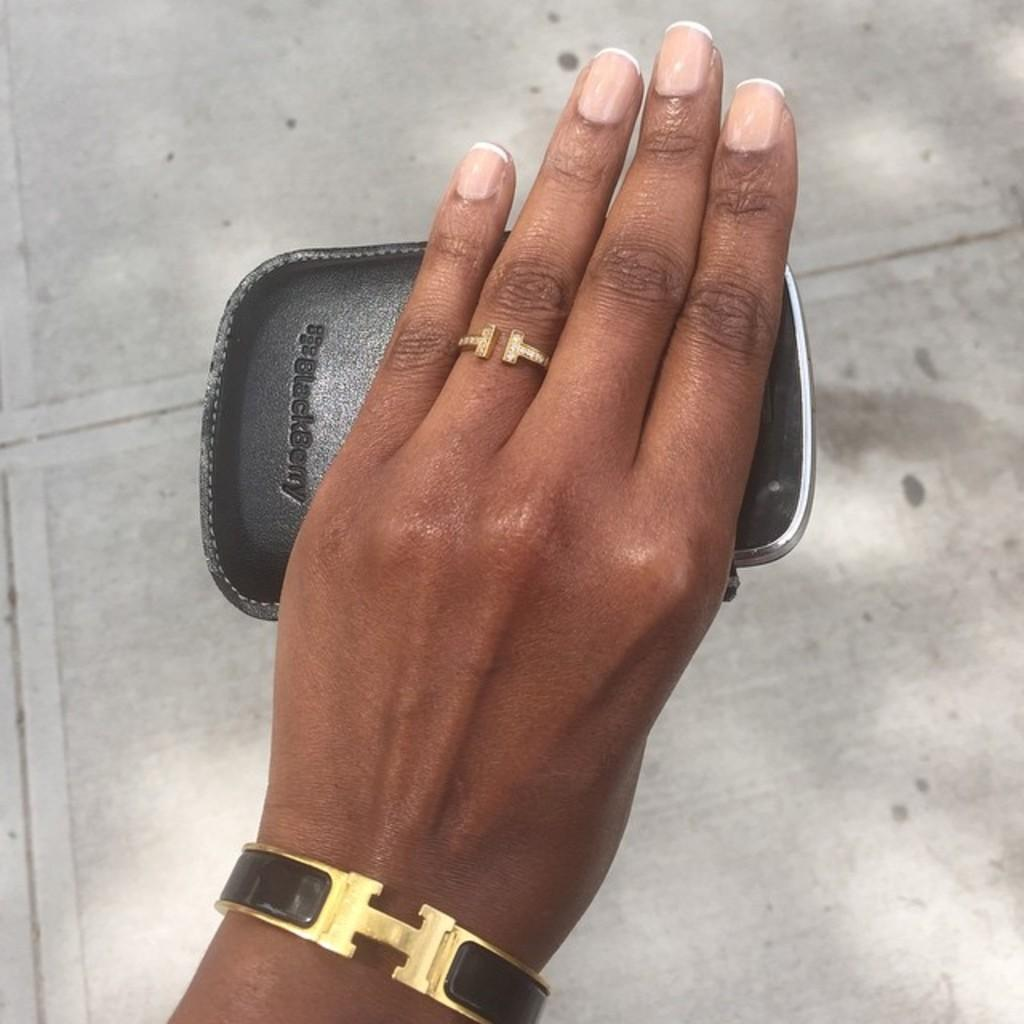<image>
Offer a succinct explanation of the picture presented. A woman's hand with an Hermes brown enamel bracelet and a ring on holding a Blackberry phone case. 